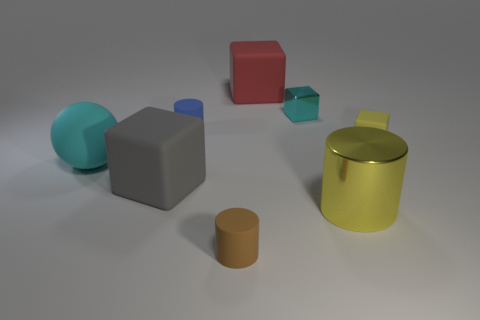There is a metal object in front of the blue thing; does it have the same size as the rubber object behind the blue cylinder? Upon observation, the metal object in front of the blue sphere appears to be of different dimensions compared to the rubber object located behind the blue cylinder. Specifically, the metal object has a distinctive cylindrical shape with a reflective golden surface and is taller, whereas the rubber object is shorter with a matte brown surface, suggesting that they do not have the same size. 